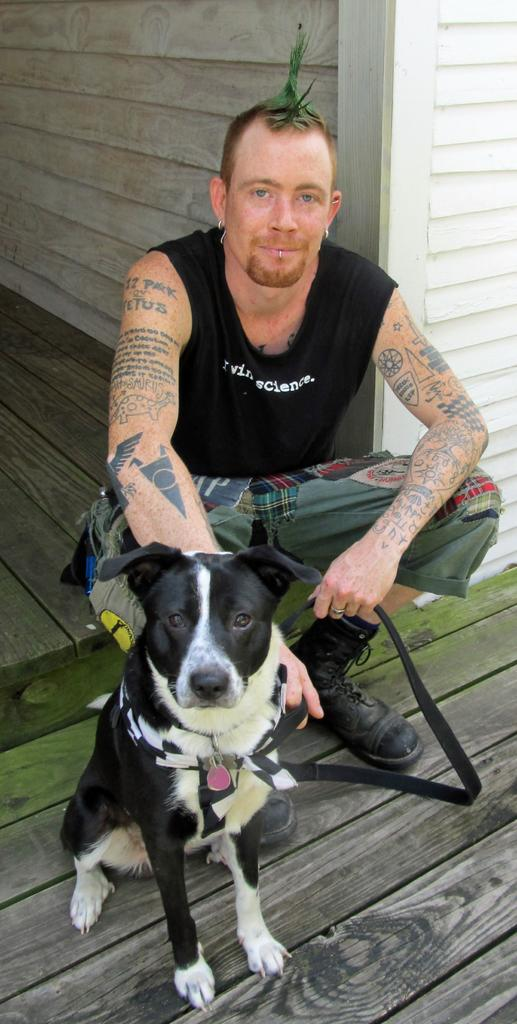What type of animal is sitting in the image? There is a dog sitting in the image. What type of person is sitting in the image? There is a man sitting in the image. What can be seen in the background of the image? There is a wooden wall in the background of the image. What type of porter is visible in the image? There is no porter present in the image. How does the dog turn around in the image? The dog does not turn around in the image; it is sitting still. 